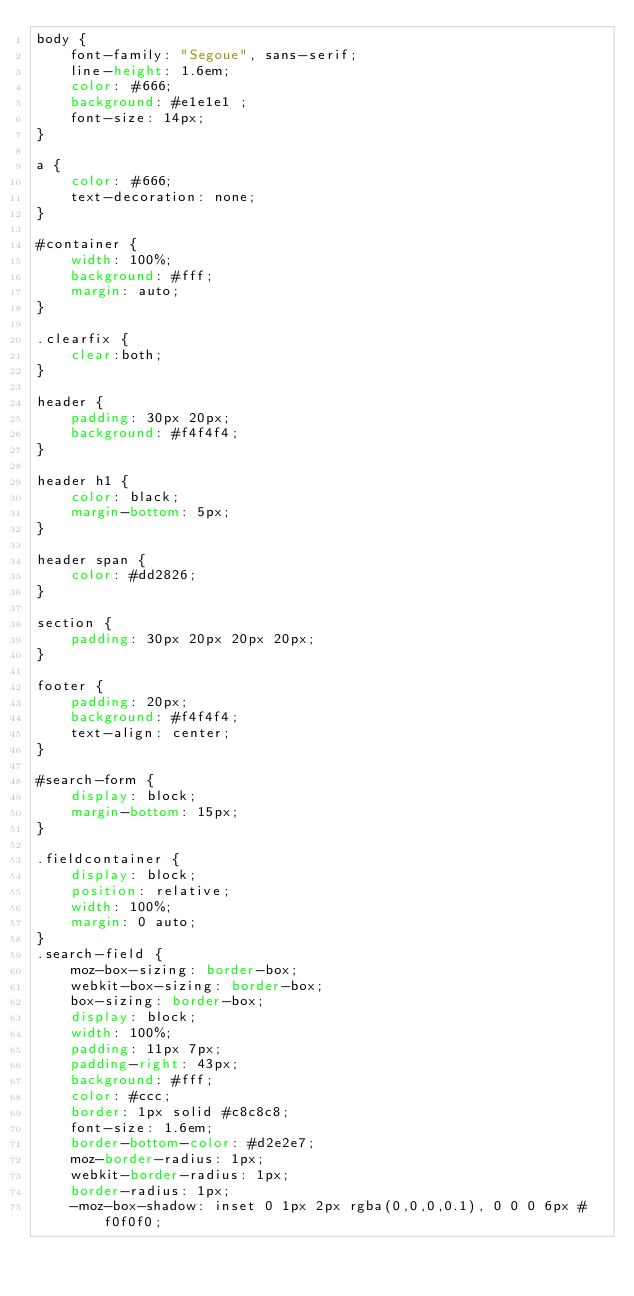<code> <loc_0><loc_0><loc_500><loc_500><_CSS_>body {
    font-family: "Segoue", sans-serif;
    line-height: 1.6em;
    color: #666;
    background: #e1e1e1 ;
    font-size: 14px;
}

a {
    color: #666;
    text-decoration: none;
}

#container {
    width: 100%;
    background: #fff;
    margin: auto;
}

.clearfix {
    clear:both;
}

header {
    padding: 30px 20px;
    background: #f4f4f4;
}

header h1 {
    color: black;
    margin-bottom: 5px;
}

header span {
    color: #dd2826;
}

section {
    padding: 30px 20px 20px 20px;
}

footer {
    padding: 20px;
    background: #f4f4f4;
    text-align: center;
}

#search-form {
    display: block;
    margin-bottom: 15px;
}

.fieldcontainer {
    display: block;
    position: relative;
    width: 100%;
    margin: 0 auto;
}
.search-field {
    moz-box-sizing: border-box;
    webkit-box-sizing: border-box;
    box-sizing: border-box;
    display: block;
    width: 100%;
    padding: 11px 7px;
    padding-right: 43px;
    background: #fff;
    color: #ccc;
    border: 1px solid #c8c8c8;
    font-size: 1.6em;
    border-bottom-color: #d2e2e7;
    moz-border-radius: 1px;
    webkit-border-radius: 1px;
    border-radius: 1px;
    -moz-box-shadow: inset 0 1px 2px rgba(0,0,0,0.1), 0 0 0 6px #f0f0f0;</code> 